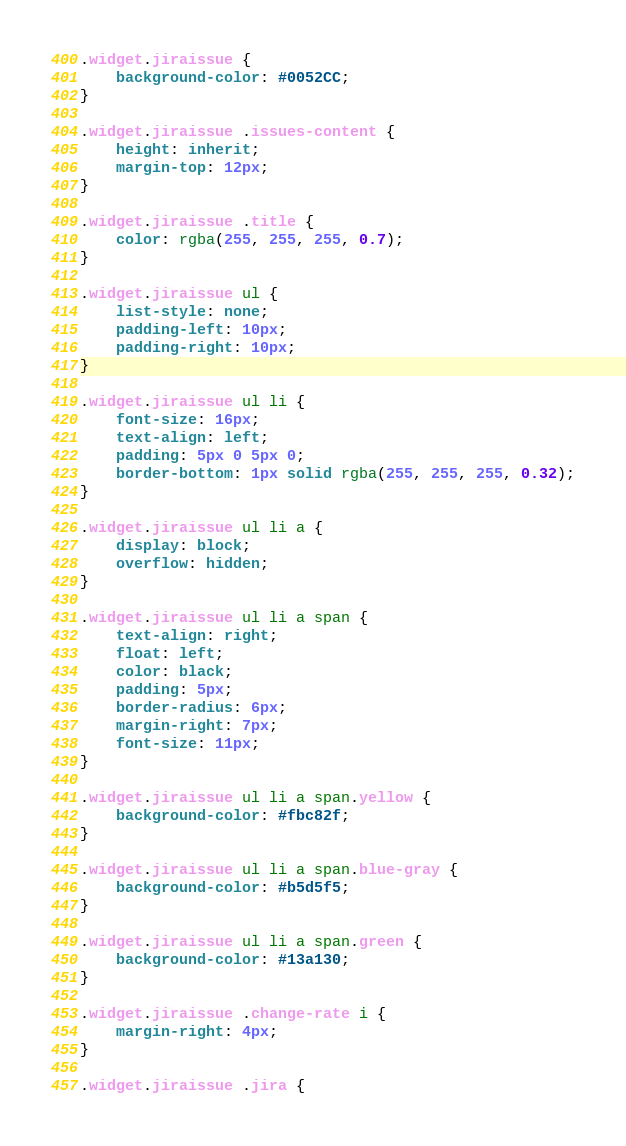Convert code to text. <code><loc_0><loc_0><loc_500><loc_500><_CSS_>.widget.jiraissue {
	background-color: #0052CC;
}

.widget.jiraissue .issues-content {
	height: inherit;
	margin-top: 12px;
}

.widget.jiraissue .title {
	color: rgba(255, 255, 255, 0.7);
}

.widget.jiraissue ul {
	list-style: none;
	padding-left: 10px;
	padding-right: 10px;
}

.widget.jiraissue ul li {
	font-size: 16px;
	text-align: left;
	padding: 5px 0 5px 0;
	border-bottom: 1px solid rgba(255, 255, 255, 0.32);
}

.widget.jiraissue ul li a {
	display: block;
	overflow: hidden;
}

.widget.jiraissue ul li a span {
	text-align: right;
	float: left;
	color: black;
	padding: 5px;
	border-radius: 6px;
	margin-right: 7px;
	font-size: 11px;
}

.widget.jiraissue ul li a span.yellow {
	background-color: #fbc82f;
}

.widget.jiraissue ul li a span.blue-gray {
	background-color: #b5d5f5;
}

.widget.jiraissue ul li a span.green {
	background-color: #13a130;
}

.widget.jiraissue .change-rate i {
	margin-right: 4px;
}

.widget.jiraissue .jira {</code> 